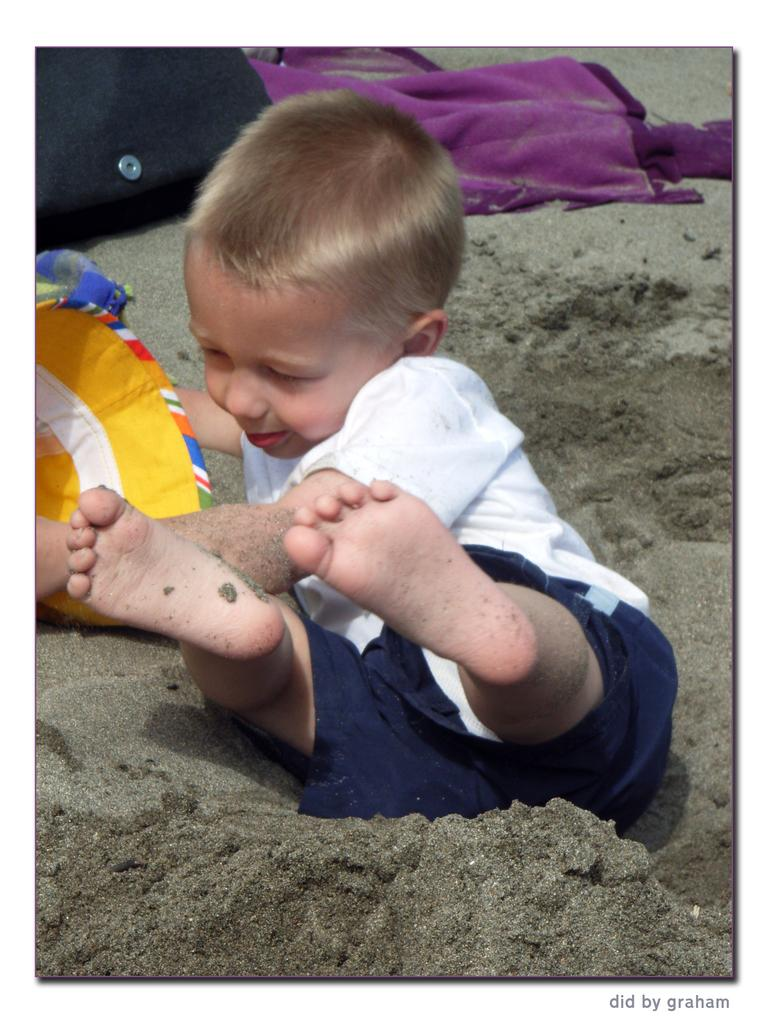What is the main subject of the image? There is a kid in the image. What is the kid wearing? The kid is wearing a white shirt. What can be seen at the top of the image? There is a cloth at the top of the image. What type of terrain is visible in the image? There is sand visible in the image. What type of calculator is the kid using in the image? There is no calculator present in the image. How does the kid use the seashore in the image? The image does not show the kid using the seashore; it only shows the kid and the sand. 